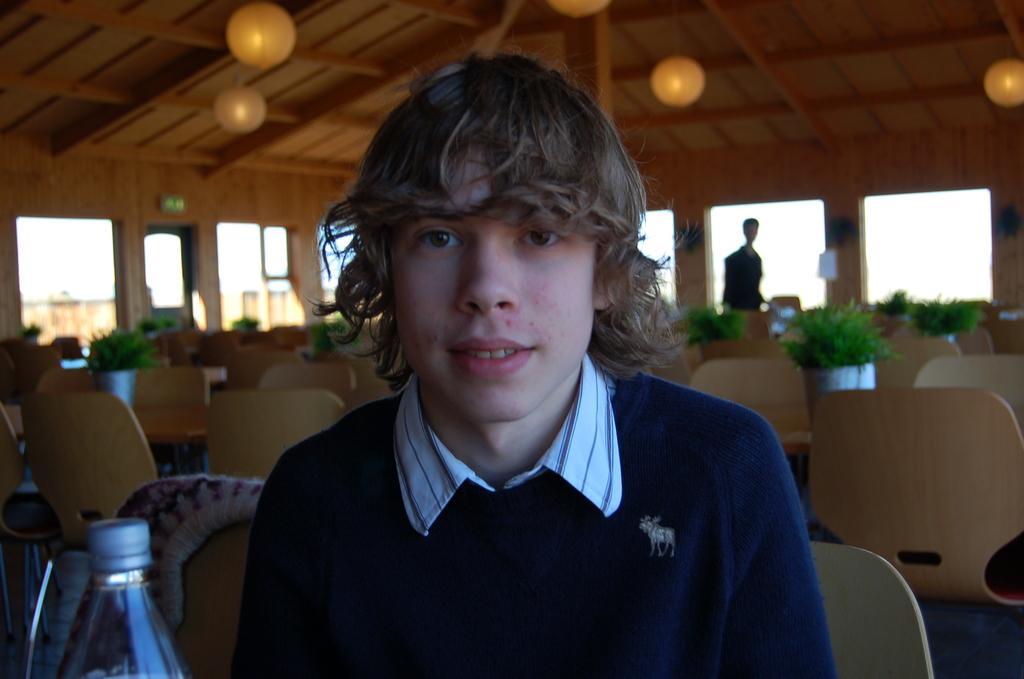Could you give a brief overview of what you see in this image? In Front portion of the picture we can see a boy sitting on a chair. We can see a bottle here. At the top we can see roof and lights. This is a door, exit board. Here we can see plants with pots on the table. On the background we can see one man standing. 